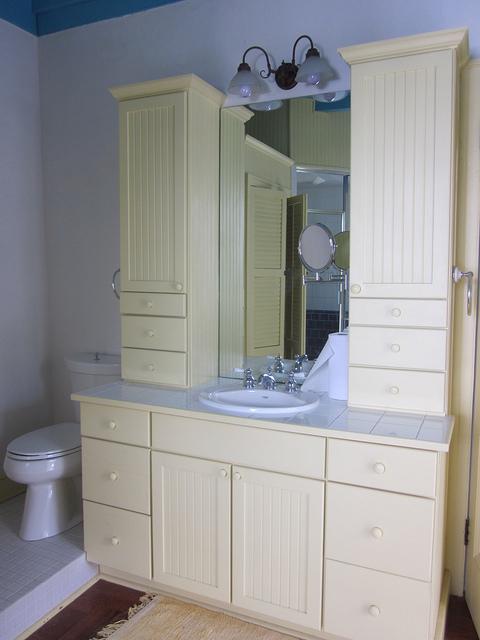What are the cabinets made of?
Be succinct. Wood. Why is the toilet raised?
Quick response, please. No idea. What kind of room is this?
Answer briefly. Bathroom. How many knobs on the dresser?
Keep it brief. 12. 